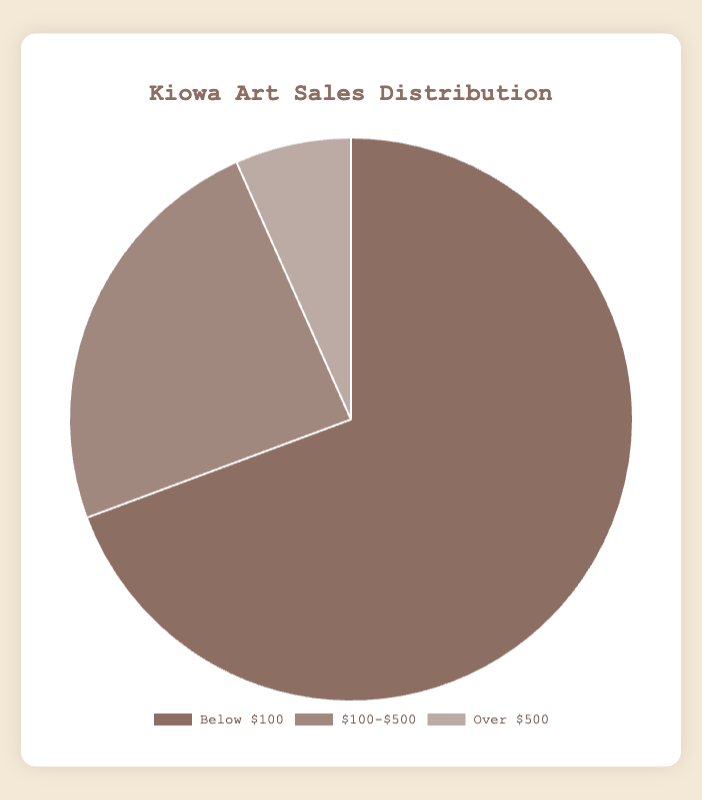Which price range has the highest sales distribution? The price range labels indicate three segments: 'Below $100', '$100-$500', and 'Over $500'. The dataset shows the sum of art pieces sold in each range: 104, 36, and 10 respectively. The highest value is found in the 'Below $100' range.
Answer: Below $100 What is the difference in the number of art pieces sold between the 'Below $100' and '$100-$500' categories? The sales for the 'Below $100' category is 104 and for the '$100-$500' category is 36. The difference is 104 - 36 = 68.
Answer: 68 How many more art pieces were sold in the 'Below $100' range compared to the 'Over $500' range? The 'Below $100' range has 104 sales and the 'Over $500' range has 10 sales. The difference is 104 - 10 = 94.
Answer: 94 What is the total number of art pieces sold across all price ranges? The sum of art pieces sold in each price range is 104 (Below $100) + 36 ($100-$500) + 10 (Over $500). The total is 104 + 36 + 10 = 150.
Answer: 150 Which color in the pie chart represents the '$100-$500' sales distribution? The code specifies different colors for each price range in the chart: '#8d6e63' for 'Below $100', '#a1887f' for '$100-$500', and '#bcaaa4' for 'Over $500'. The color for the '$100-$500' range is dark brown or light brown depending on personal interpretation, but according to the code, it's light brown.
Answer: Light brown Is the 'Over $500' category the smallest segment in the pie chart? The sales data shows the 'Over $500' category has 10 units, which is the smallest value compared to 104 (Below $100) and 36 ($100-$500). Therefore, it will visually appear as the smallest segment.
Answer: Yes What is the ratio of art pieces sold 'Below $100' to '$100-$500'? 'Below $100' has 104 sales and '$100-$500' has 36 sales. The ratio is 104:36, which can be simplified to approximately 2.89:1.
Answer: 2.89:1 What fraction of total sales does the '$100-$500' category represent? The '$100-$500' category sold 36 pieces out of a total 150 pieces (104 + 36 + 10). The fraction is 36/150, which simplifies to 24/100 or 24%.
Answer: 24% If you combine the 'Over $500' and '$100-$500' sales, how does it compare to the 'Below $100' sales? Combined sales for 'Over $500' and '$100-$500' are 10 + 36 = 46. The 'Below $100' sales are 104. Comparison shows that 104 is more than double the combined 46.
Answer: More than double 